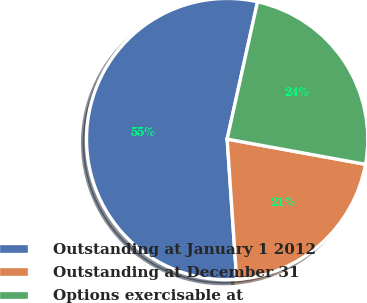Convert chart to OTSL. <chart><loc_0><loc_0><loc_500><loc_500><pie_chart><fcel>Outstanding at January 1 2012<fcel>Outstanding at December 31<fcel>Options exercisable at<nl><fcel>54.54%<fcel>21.05%<fcel>24.4%<nl></chart> 